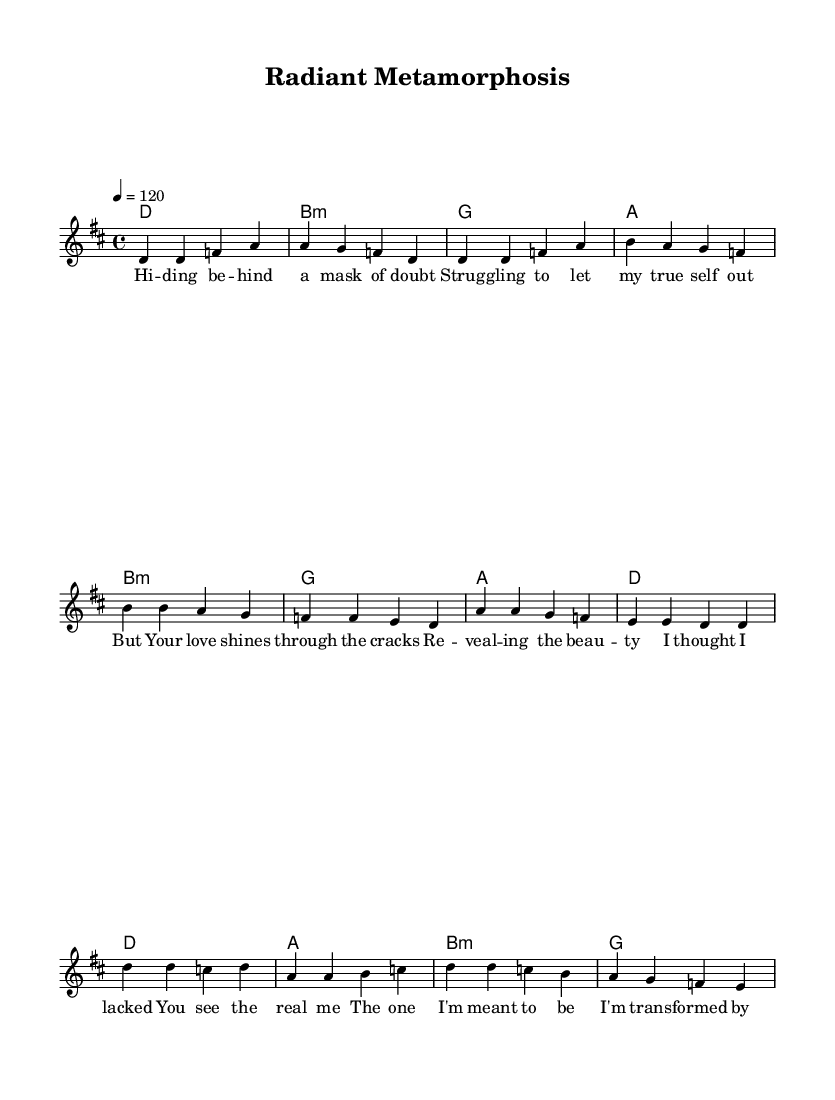What is the key signature of this music? The key signature is D major, which has two sharps (F# and C#).
Answer: D major What is the time signature of this music? The time signature is 4/4, meaning there are four beats in each measure and the quarter note gets one beat.
Answer: 4/4 What is the tempo marking of the piece? The tempo is marked at 120 beats per minute, indicated by the term "tempo 4 = 120".
Answer: 120 How many sections are in the song structure? The song consists of three main sections: verse, pre-chorus, and chorus, making it a structured format for easier performance and comprehension.
Answer: Three What is the main theme of the lyrics? The lyrics focus on personal transformation and embracing one's true self through the light of divine grace, illustrating a journey from doubt to confidence.
Answer: Transformation Which chord is used most frequently in the verse? The D major chord is the primary chord used in the verse, providing the foundational harmony for the opening lines.
Answer: D What emotion do the lyrics convey in the chorus? The chorus expresses joy and empowerment through the transformative experience of divine grace, reflecting positivity and self-acceptance.
Answer: Joy 